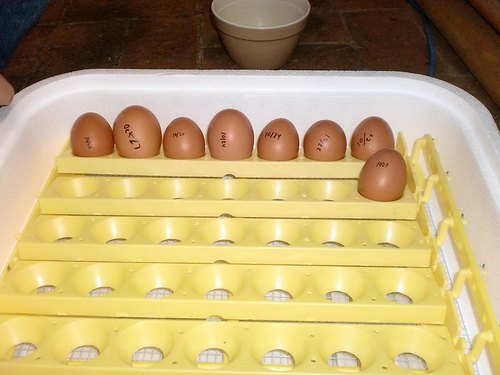<image>
Is the egg above the carton? No. The egg is not positioned above the carton. The vertical arrangement shows a different relationship. 